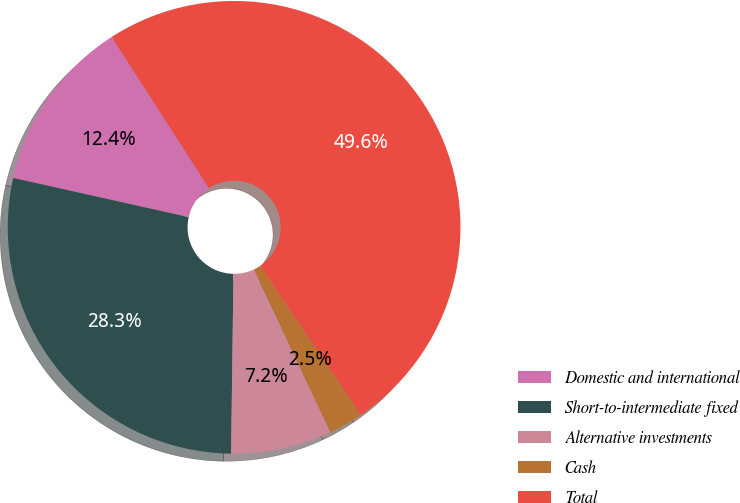Convert chart. <chart><loc_0><loc_0><loc_500><loc_500><pie_chart><fcel>Domestic and international<fcel>Short-to-intermediate fixed<fcel>Alternative investments<fcel>Cash<fcel>Total<nl><fcel>12.41%<fcel>28.29%<fcel>7.2%<fcel>2.48%<fcel>49.63%<nl></chart> 